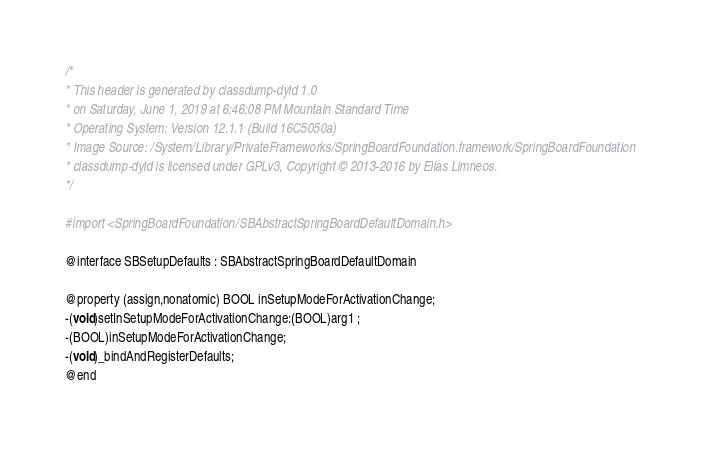<code> <loc_0><loc_0><loc_500><loc_500><_C_>/*
* This header is generated by classdump-dyld 1.0
* on Saturday, June 1, 2019 at 6:46:08 PM Mountain Standard Time
* Operating System: Version 12.1.1 (Build 16C5050a)
* Image Source: /System/Library/PrivateFrameworks/SpringBoardFoundation.framework/SpringBoardFoundation
* classdump-dyld is licensed under GPLv3, Copyright © 2013-2016 by Elias Limneos.
*/

#import <SpringBoardFoundation/SBAbstractSpringBoardDefaultDomain.h>

@interface SBSetupDefaults : SBAbstractSpringBoardDefaultDomain

@property (assign,nonatomic) BOOL inSetupModeForActivationChange; 
-(void)setInSetupModeForActivationChange:(BOOL)arg1 ;
-(BOOL)inSetupModeForActivationChange;
-(void)_bindAndRegisterDefaults;
@end

</code> 